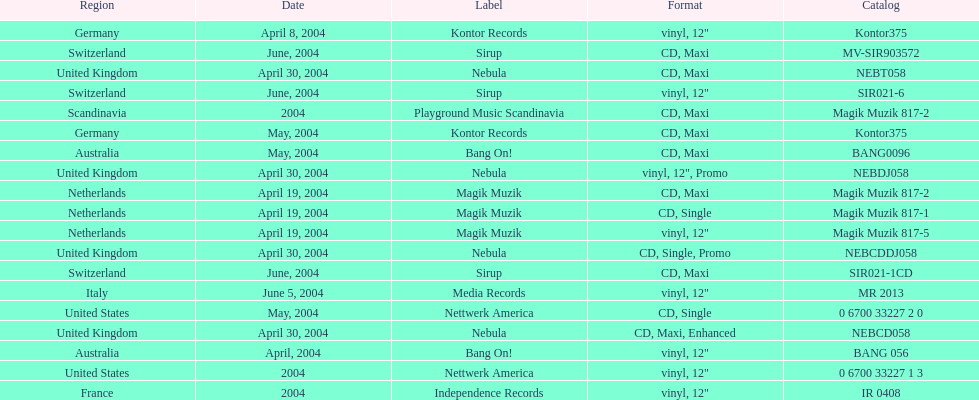What label was used by the netherlands in love comes again? Magik Muzik. What label was used in germany? Kontor Records. What label was used in france? Independence Records. 